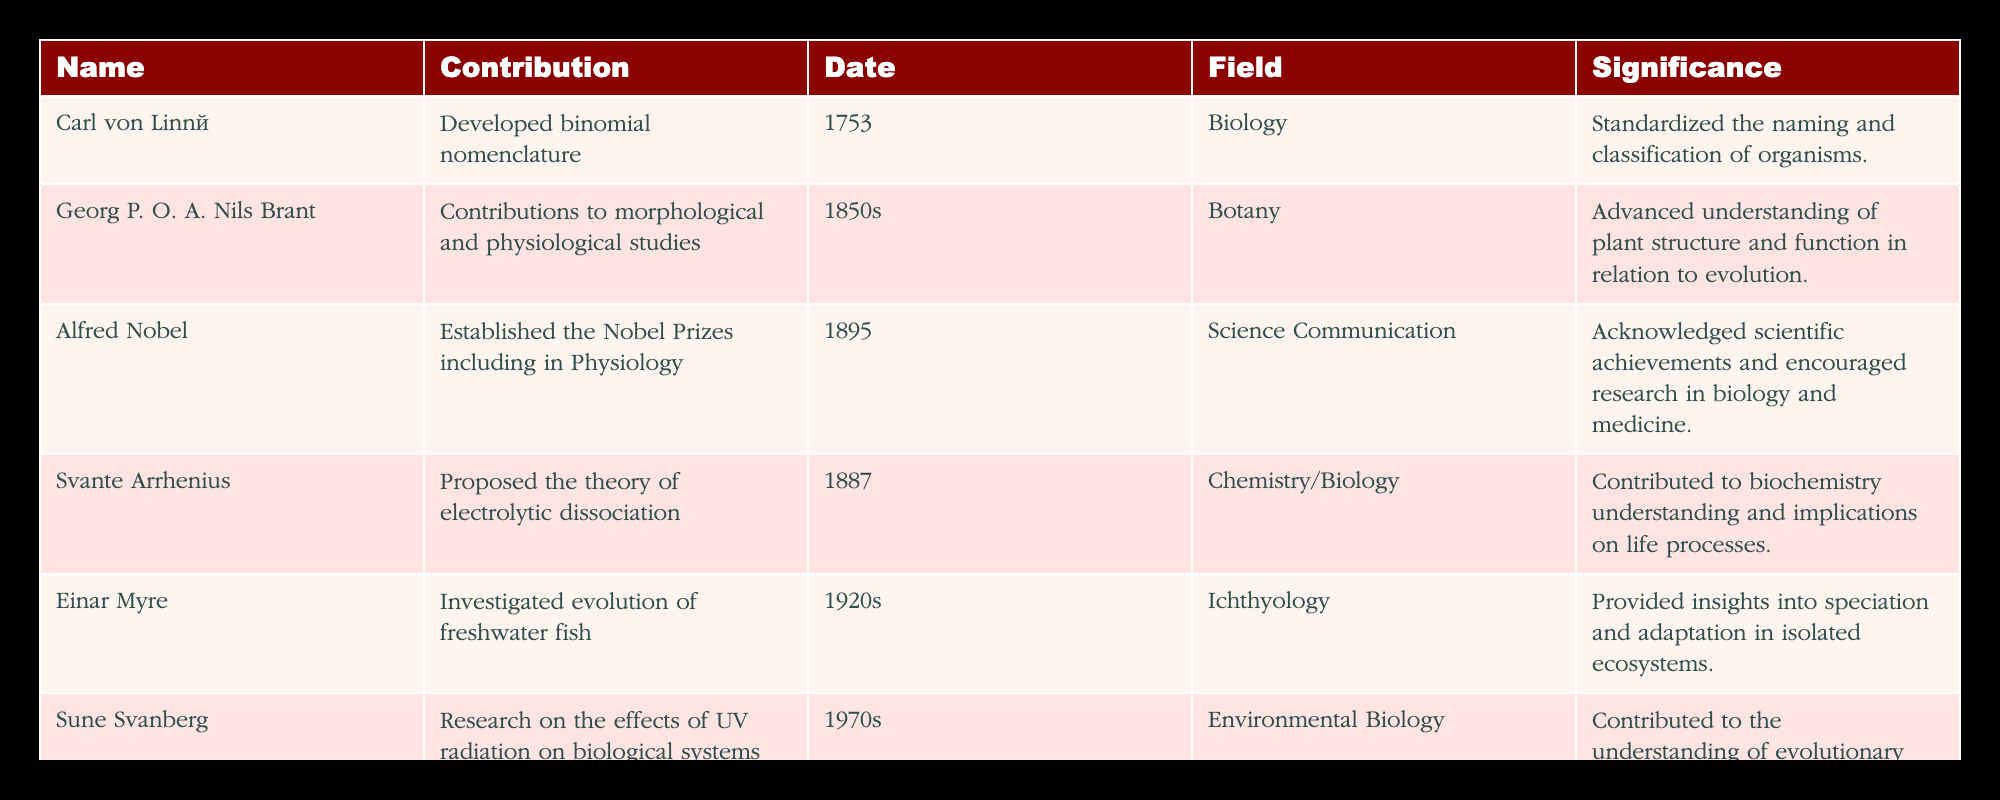What is Carl von Linné known for? Carl von Linné is known for developing binomial nomenclature, which is a system for naming and classifying organisms. This information can be found in the 'Contribution' column next to his name in the table.
Answer: Developed binomial nomenclature Who contributed to studies on freshwater fish? Einar Myre investigated the evolution of freshwater fish. This is explicitly mentioned under his name in the 'Contribution' column of the table.
Answer: Einar Myre How many contributors in the table worked in the field of biology or related areas? The fields listed for contributors are Biology, Botany, Science Communication, Chemistry/Biology, Ichthyology, and Environmental Biology. All fields are related to biology, leading to a total of 6 contributors.
Answer: 6 Which researcher established the Nobel Prizes? Alfred Nobel established the Nobel Prizes, which is mentioned in his entry under 'Contribution' in the table.
Answer: Alfred Nobel Was Svante Arrhenius's contribution in the 20th century? No, Svante Arrhenius's contribution was made in 1887, which places it in the 19th century, as can be verified with the 'Date' column in the table.
Answer: No Who had contributions focused on ultraviolet radiation? Sune Svanberg focused on UV radiation's effects on biological systems. This can be identified from the 'Contribution' column in his row.
Answer: Sune Svanberg What is the chronological order of the contributions listed in the table? The chronological order, based on the 'Date' column, is: Carl von Linné (1753), Georg P. O. A. Nils Brant (1850s), Svante Arrhenius (1887), Alfred Nobel (1895), Einar Myre (1920s), and Sune Svanberg (1970s). This requires checking each date and arranging them accordingly.
Answer: 1753, 1850s, 1887, 1895, 1920s, 1970s What contribution did Georg P. O. A. Nils Brant make? Georg P. O. A. Nils Brant made contributions to morphological and physiological studies in botany, as stated under his name in the 'Contribution' column.
Answer: Contributions to morphological and physiological studies How many years are there between the first contribution and the last contribution in the table? The first contribution is in 1753 and the last in the 1970s. The approximate last date can be taken as 1979. Calculating gives us 1979 - 1753 = 226 years.
Answer: 226 years 